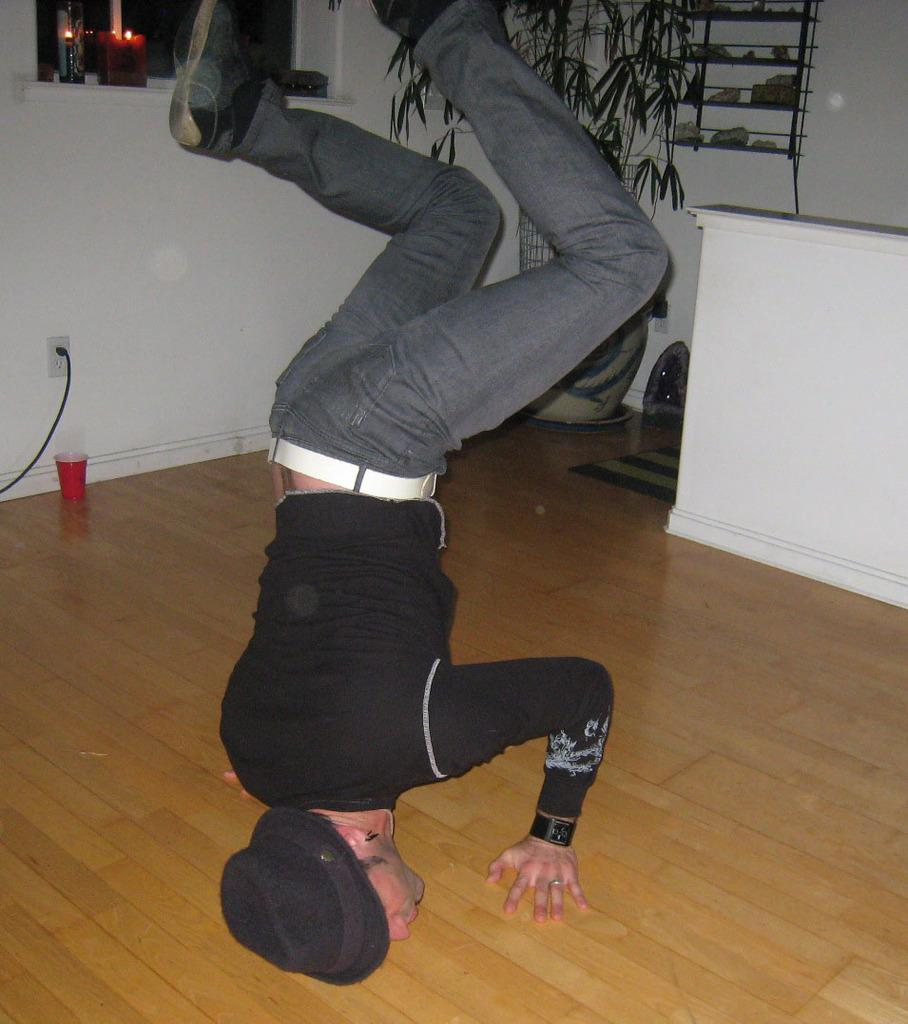What is the main subject in the middle of the image? There is a man in the middle of the image. What is the man doing in the image? The man is doing something, but we cannot determine the specific action from the facts provided. What can be seen behind the man? There is a plant behind the man. What is located behind the plant? There is a table behind the plant. What is on the table? There is a cup on the table. What is on the wall behind the table? There are candles on the wall. What type of heart condition does the man have in the image? There is no information about the man's health or any heart condition in the image. What company is the man representing in the image? There is no indication of any company or affiliation in the image. 